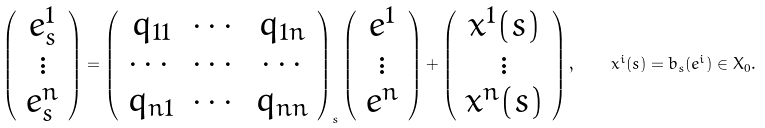<formula> <loc_0><loc_0><loc_500><loc_500>\left ( \begin{array} { c } e _ { s } ^ { 1 } \\ \vdots \\ e _ { s } ^ { n } \end{array} \right ) = \left ( \begin{array} { c c c } q _ { 1 1 } & \cdots & q _ { 1 n } \\ \cdots & \cdots & \cdots \\ q _ { n 1 } & \cdots & q _ { n n } \end{array} \right ) _ { s } \left ( \begin{array} { c } e ^ { 1 } \\ \vdots \\ e ^ { n } \end{array} \right ) + \left ( \begin{array} { c } x ^ { 1 } ( s ) \\ \vdots \\ x ^ { n } ( s ) \end{array} \right ) , \quad x ^ { i } ( s ) = b _ { s } ( e ^ { i } ) \in X _ { 0 } .</formula> 